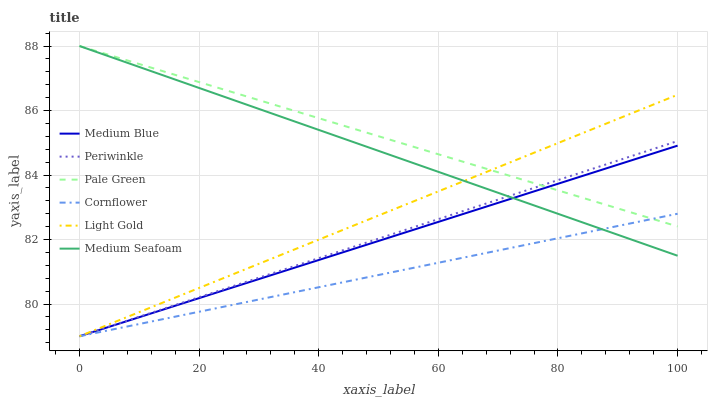Does Cornflower have the minimum area under the curve?
Answer yes or no. Yes. Does Pale Green have the maximum area under the curve?
Answer yes or no. Yes. Does Medium Blue have the minimum area under the curve?
Answer yes or no. No. Does Medium Blue have the maximum area under the curve?
Answer yes or no. No. Is Light Gold the smoothest?
Answer yes or no. Yes. Is Medium Seafoam the roughest?
Answer yes or no. Yes. Is Medium Blue the smoothest?
Answer yes or no. No. Is Medium Blue the roughest?
Answer yes or no. No. Does Cornflower have the lowest value?
Answer yes or no. Yes. Does Pale Green have the lowest value?
Answer yes or no. No. Does Medium Seafoam have the highest value?
Answer yes or no. Yes. Does Medium Blue have the highest value?
Answer yes or no. No. Does Medium Blue intersect Cornflower?
Answer yes or no. Yes. Is Medium Blue less than Cornflower?
Answer yes or no. No. Is Medium Blue greater than Cornflower?
Answer yes or no. No. 